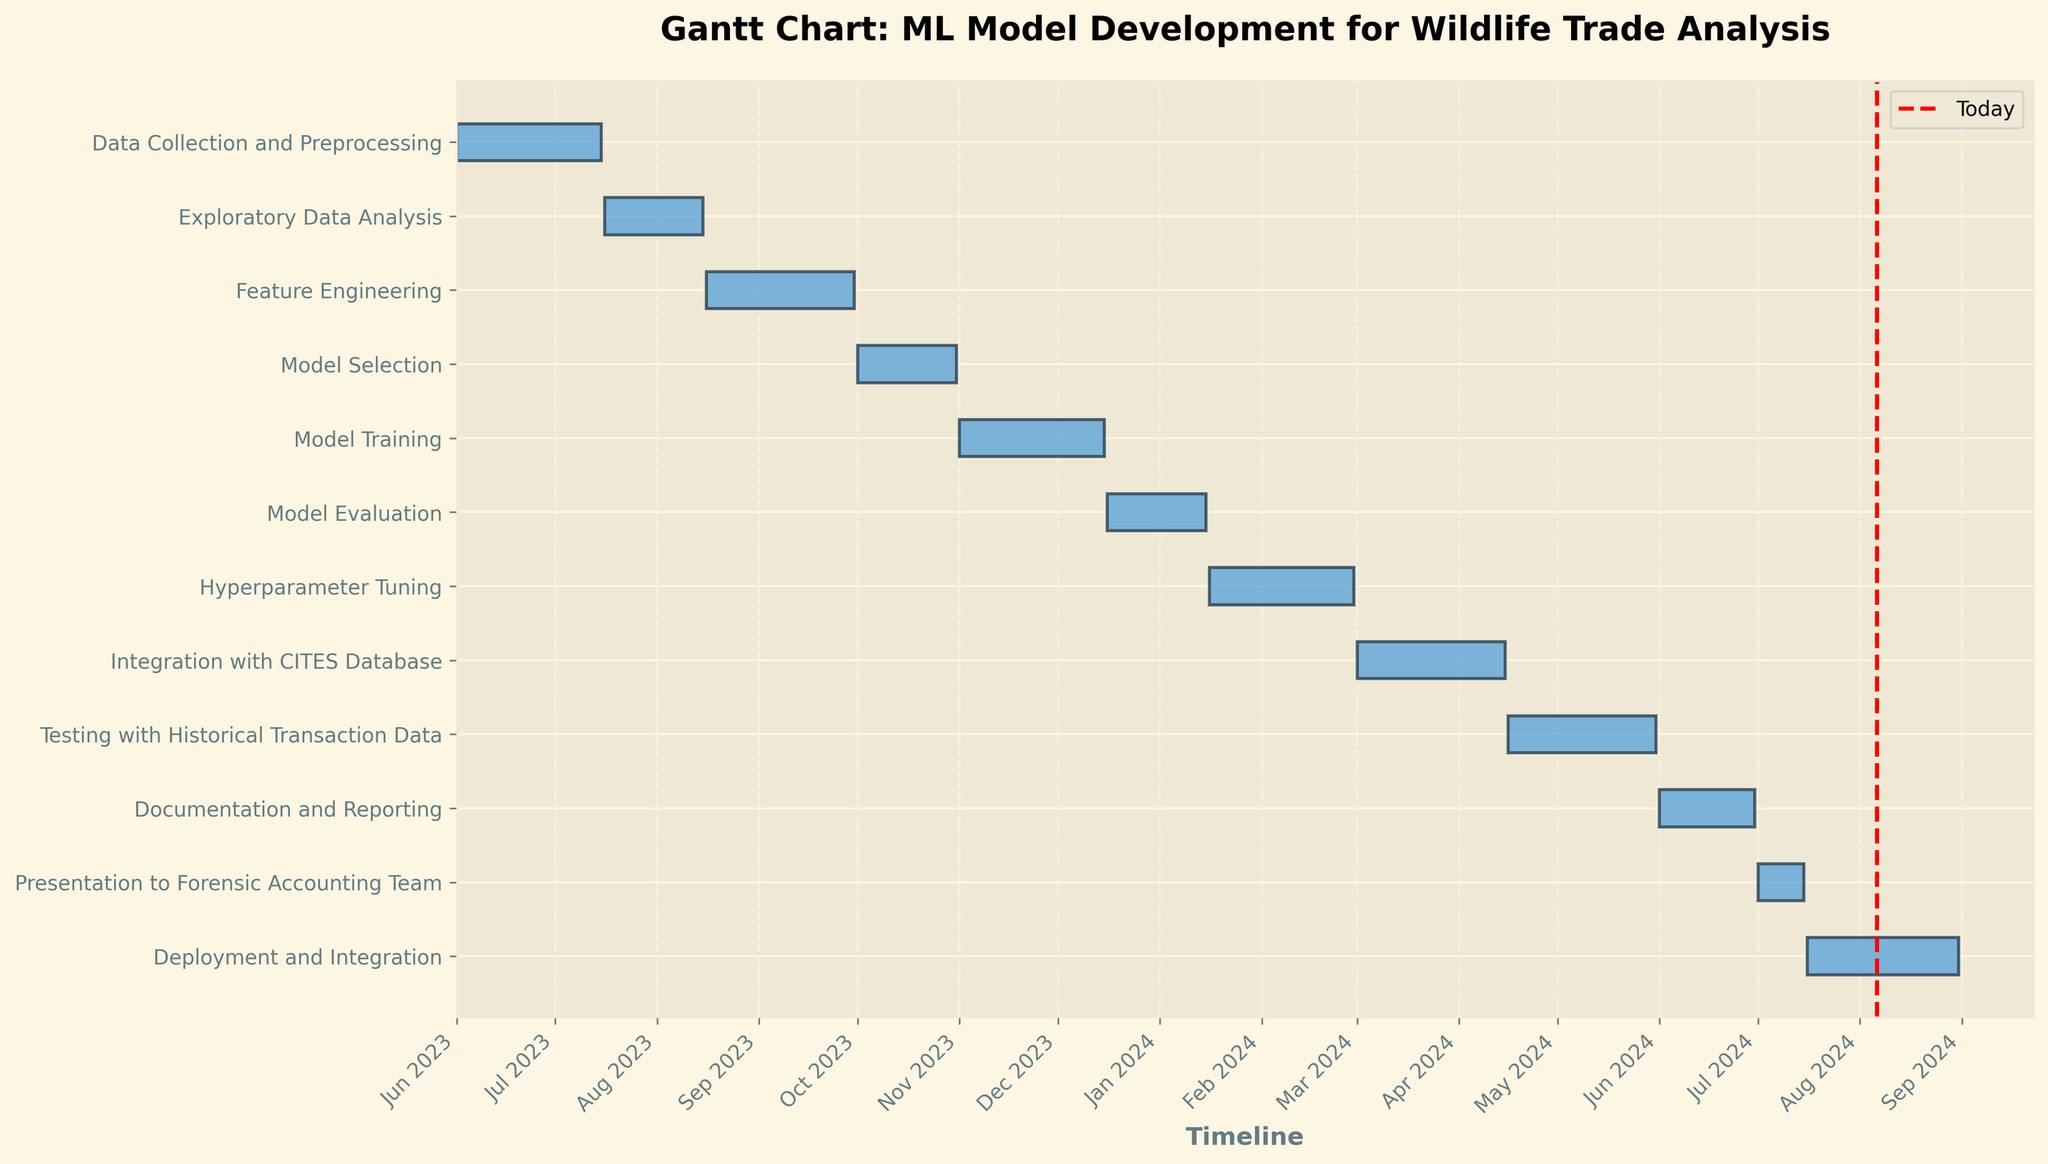When does the "Exploratory Data Analysis" phase start and end? By referring to the figure, you can see the starting and ending points of each task along the timeline. "Exploratory Data Analysis" starts on July 16, 2023, and ends on August 15, 2023.
Answer: Starts on July 16, 2023, and ends on August 15, 2023 How long is the "Model Training" phase? The duration of tasks can be calculated by subtracting the start date from the end date. "Model Training" starts on November 1, 2023, and ends on December 15, 2023. Therefore, the duration is December 15 - November 1 = 45 days.
Answer: 45 days What tasks are planned to take place in February 2024? Tasks taking place in any given month can be observed by overlapping their duration with the corresponding date range on the timeline. "Hyperparameter Tuning" spans February 2024.
Answer: Hyperparameter Tuning Which stage has the shortest duration? To determine the shortest duration, compare the lengths of the bars for each task. "Presentation to Forensic Accounting Team" has the shortest duration from July 1, 2024, to July 15, 2024, which is 15 days.
Answer: Presentation to Forensic Accounting Team Which phase directly follows "Model Training"? Tasks and their sequence can be tracked linearly by the end and subsequent start dates. "Model Evaluation" follows "Model Training," starting on December 16, 2023.
Answer: Model Evaluation How many tasks are scheduled after January 2024? Check the timeline for the number of tasks starting after January 1, 2024. There are six tasks scheduled after this date.
Answer: Six tasks What's the total duration from "Data Collection and Preprocessing" to "Deployment and Integration"? The total duration can be found by calculating the time from the start of "Data Collection and Preprocessing" (June 1, 2023) to the end of "Deployment and Integration" (August 31, 2024). This is a span from June 1, 2023, to August 31, 2024, which totals 458 days.
Answer: 458 days Is "Model Selection" scheduled to be completed before the end of 2023? To verify this, check the end date of "Model Selection." It ends on October 31, 2023, which is before the end of 2023.
Answer: Yes Which task overlaps with "Documentation and Reporting"? Overlapping tasks can be identified by observing the timeline bars for concurrent time periods. "Testing with Historical Transaction Data" overlaps with "Documentation and Reporting" as it ends on May 31, 2024, and the latter starts on June 1, 2024.
Answer: Testing with Historical Transaction Data 